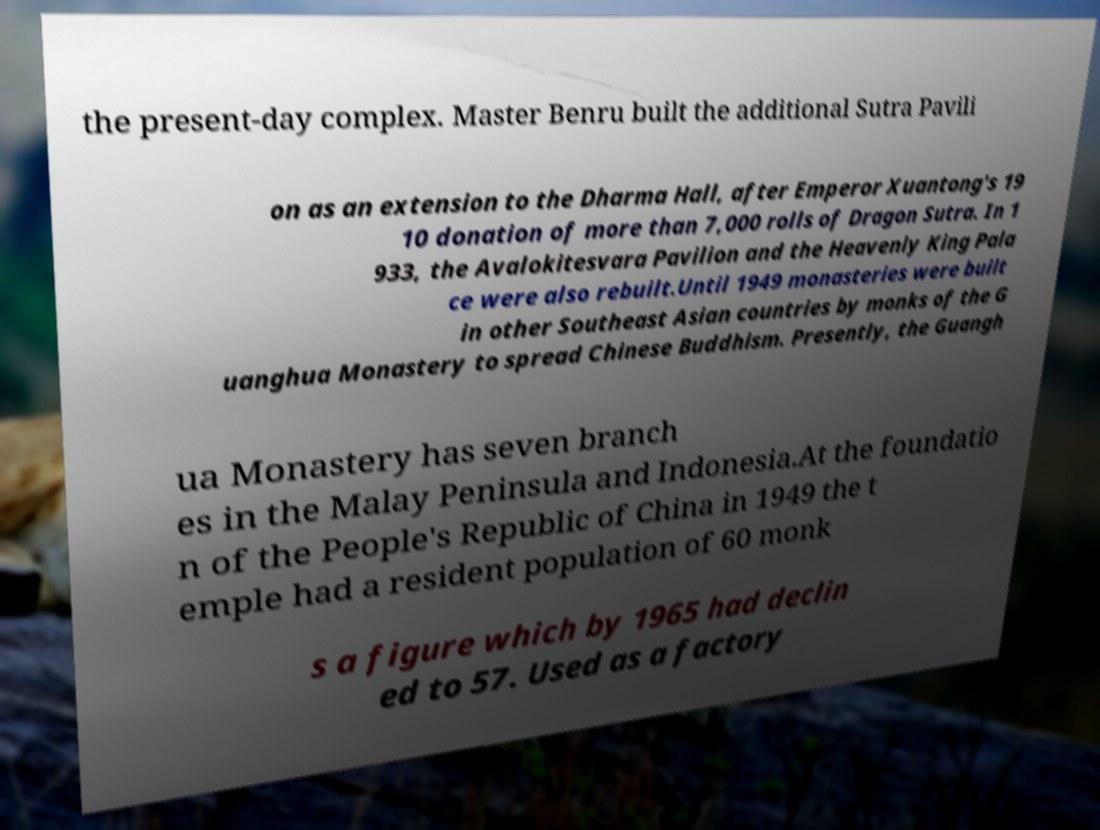Please identify and transcribe the text found in this image. the present-day complex. Master Benru built the additional Sutra Pavili on as an extension to the Dharma Hall, after Emperor Xuantong's 19 10 donation of more than 7,000 rolls of Dragon Sutra. In 1 933, the Avalokitesvara Pavilion and the Heavenly King Pala ce were also rebuilt.Until 1949 monasteries were built in other Southeast Asian countries by monks of the G uanghua Monastery to spread Chinese Buddhism. Presently, the Guangh ua Monastery has seven branch es in the Malay Peninsula and Indonesia.At the foundatio n of the People's Republic of China in 1949 the t emple had a resident population of 60 monk s a figure which by 1965 had declin ed to 57. Used as a factory 